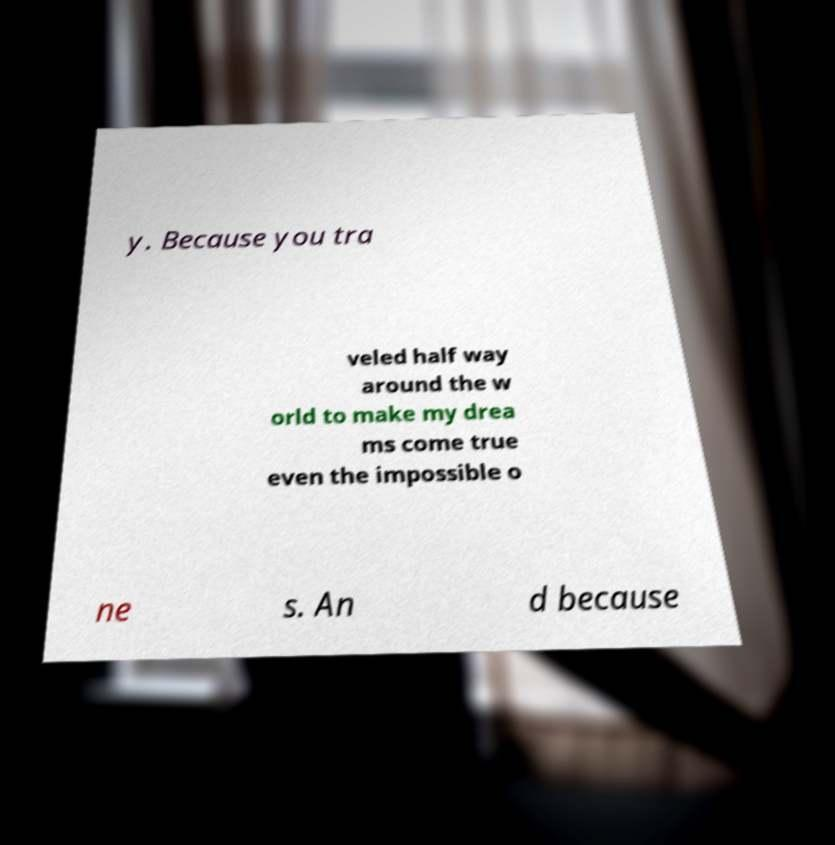Can you accurately transcribe the text from the provided image for me? y. Because you tra veled half way around the w orld to make my drea ms come true even the impossible o ne s. An d because 